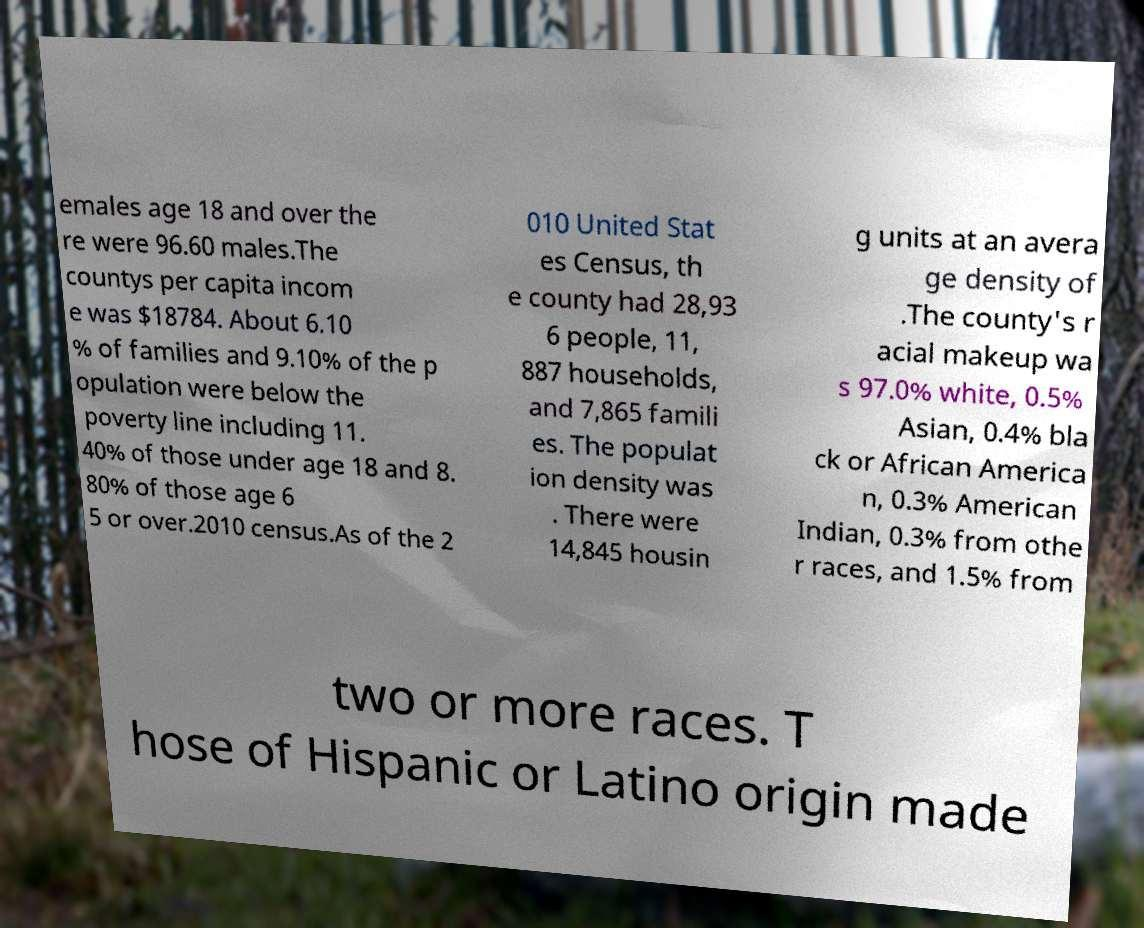Please read and relay the text visible in this image. What does it say? emales age 18 and over the re were 96.60 males.The countys per capita incom e was $18784. About 6.10 % of families and 9.10% of the p opulation were below the poverty line including 11. 40% of those under age 18 and 8. 80% of those age 6 5 or over.2010 census.As of the 2 010 United Stat es Census, th e county had 28,93 6 people, 11, 887 households, and 7,865 famili es. The populat ion density was . There were 14,845 housin g units at an avera ge density of .The county's r acial makeup wa s 97.0% white, 0.5% Asian, 0.4% bla ck or African America n, 0.3% American Indian, 0.3% from othe r races, and 1.5% from two or more races. T hose of Hispanic or Latino origin made 